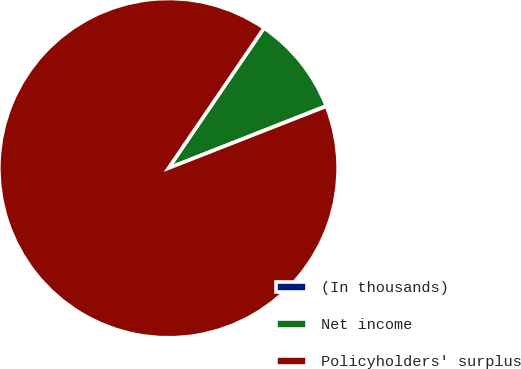Convert chart. <chart><loc_0><loc_0><loc_500><loc_500><pie_chart><fcel>(In thousands)<fcel>Net income<fcel>Policyholders' surplus<nl><fcel>0.04%<fcel>9.49%<fcel>90.47%<nl></chart> 